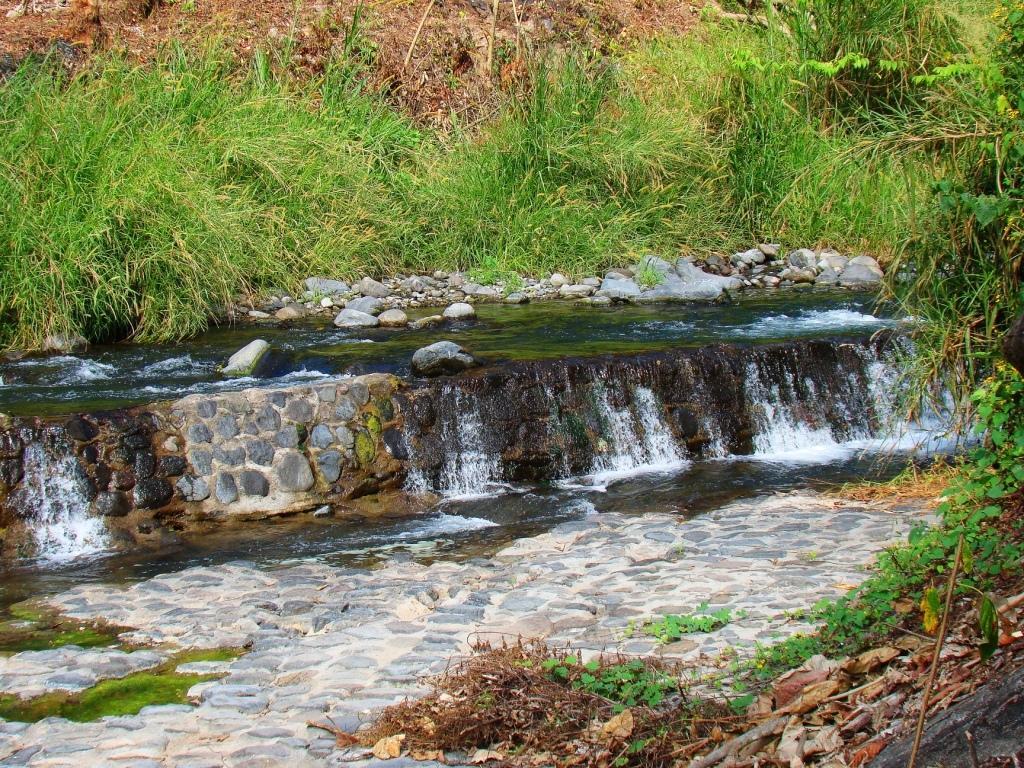How would you summarize this image in a sentence or two? In this picture we can see water fall, side we can see some rocks and around we can see the grass. 